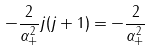Convert formula to latex. <formula><loc_0><loc_0><loc_500><loc_500>- \frac { 2 } { \alpha _ { + } ^ { 2 } } j ( j + 1 ) = - \frac { 2 } { \alpha _ { + } ^ { 2 } }</formula> 